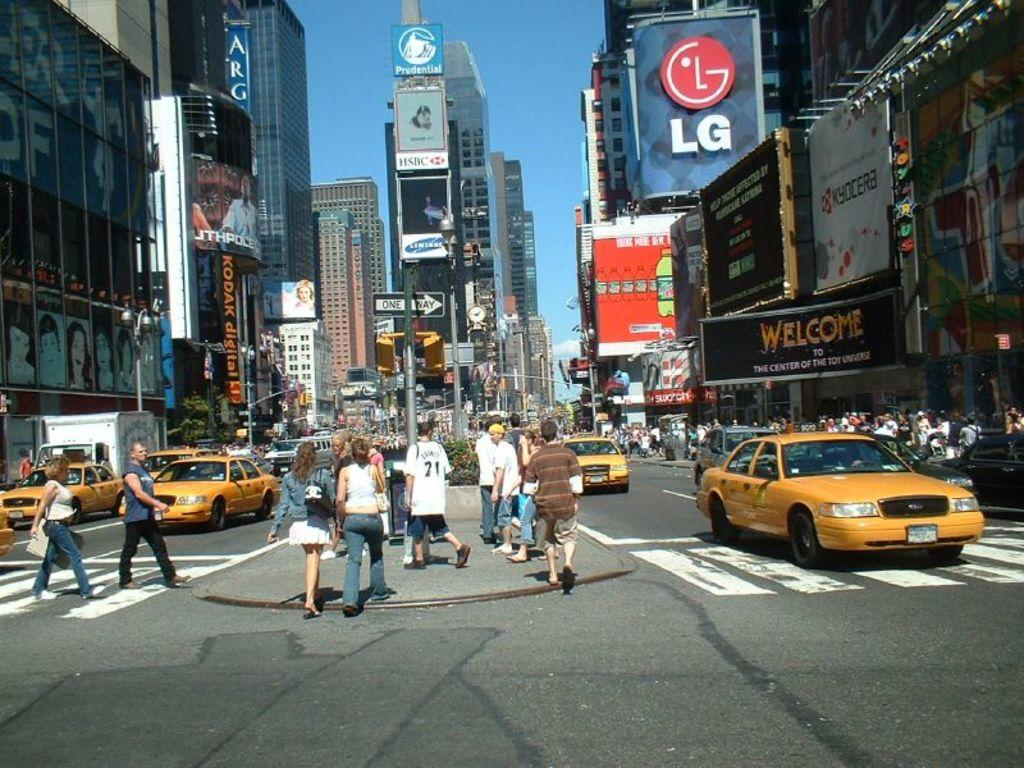<image>
Summarize the visual content of the image. A busy city street has an LG sign on the right, and a Kodak digital sign on the left, amidst many others. 